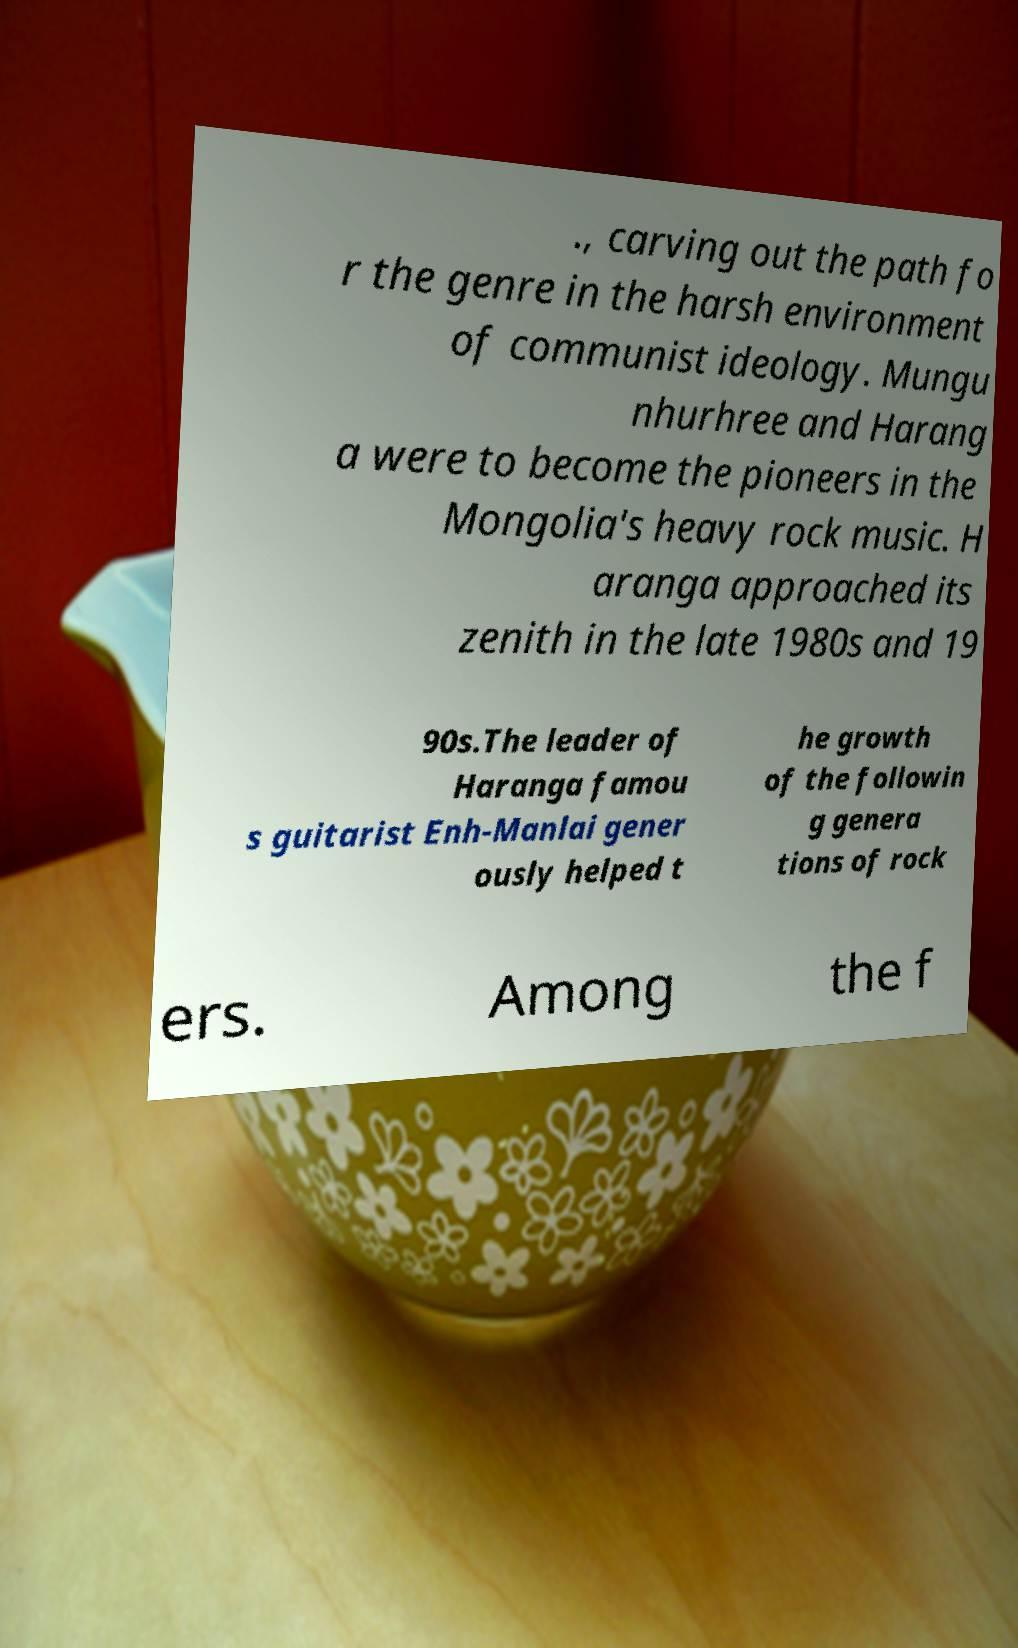I need the written content from this picture converted into text. Can you do that? ., carving out the path fo r the genre in the harsh environment of communist ideology. Mungu nhurhree and Harang a were to become the pioneers in the Mongolia's heavy rock music. H aranga approached its zenith in the late 1980s and 19 90s.The leader of Haranga famou s guitarist Enh-Manlai gener ously helped t he growth of the followin g genera tions of rock ers. Among the f 